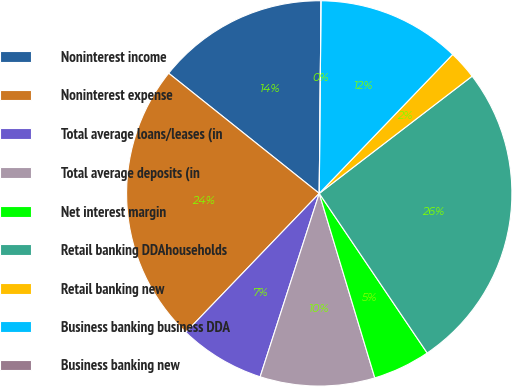Convert chart. <chart><loc_0><loc_0><loc_500><loc_500><pie_chart><fcel>Noninterest income<fcel>Noninterest expense<fcel>Total average loans/leases (in<fcel>Total average deposits (in<fcel>Net interest margin<fcel>Retail banking DDAhouseholds<fcel>Retail banking new<fcel>Business banking business DDA<fcel>Business banking new<nl><fcel>14.43%<fcel>23.54%<fcel>7.22%<fcel>9.62%<fcel>4.81%<fcel>25.95%<fcel>2.41%<fcel>12.03%<fcel>0.0%<nl></chart> 